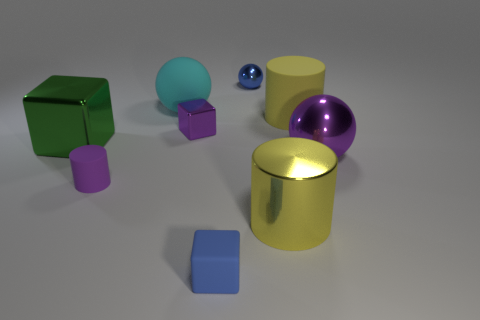What can you infer about the texture of the objects? The objects exhibit a variety of textures. The golden cylinder and the purple sphere have smooth surfaces reflecting light sharply, implying they are likely metallic or made of a glossy material. The blue cube looks slightly grainy indicating a rougher texture. These textures contribute to the tactile perception of the objects, suggesting how they might feel to touch.  Are there any indications about the relative weight of the objects? While we cannot definitively determine weight from a static image, we can make educated guesses based on visual cues and material assumptions. If we assume that the objects are made of common materials that match their appearance, the metallic-looking cylinder and spheres would be heavier than the blocks, which could be made from lighter substances such as plastic or wood. 